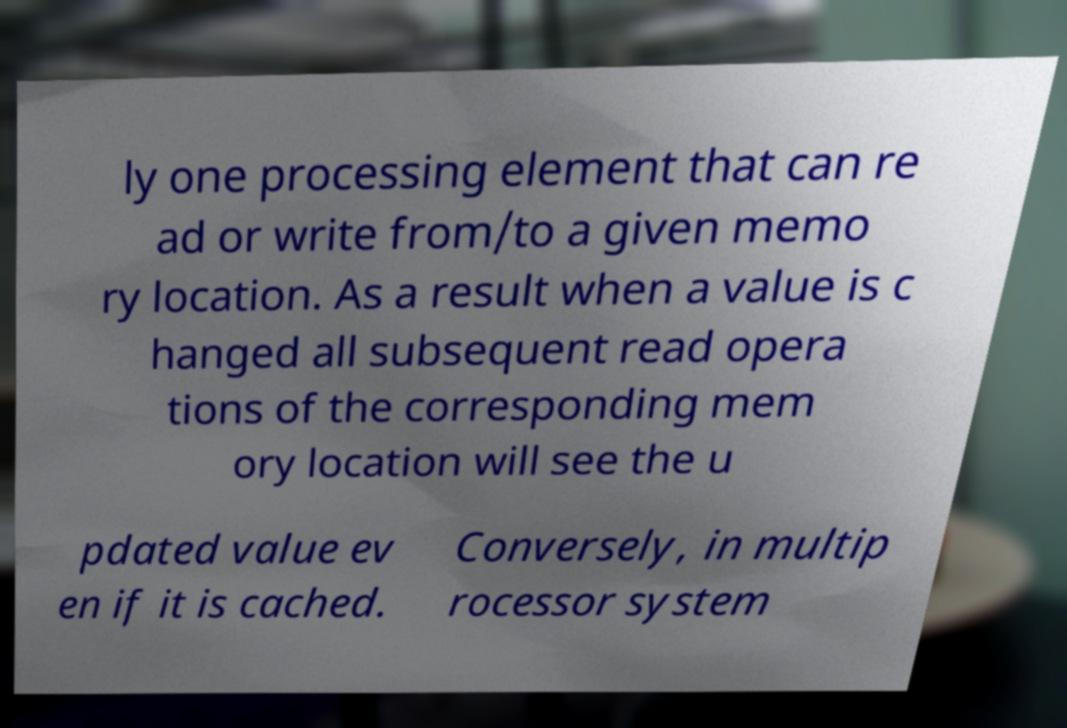Please read and relay the text visible in this image. What does it say? ly one processing element that can re ad or write from/to a given memo ry location. As a result when a value is c hanged all subsequent read opera tions of the corresponding mem ory location will see the u pdated value ev en if it is cached. Conversely, in multip rocessor system 